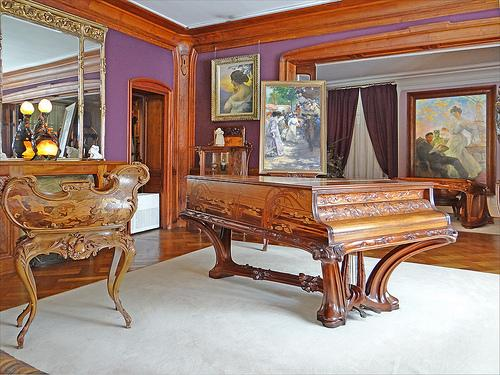Provide a concise description of the central item in the image and the color palette that dominates the scene. An engraved antique piano on a white rug highlights the scene, while tones of brown, white, and purple dominate the room's color scheme. Imagine that you are giving an audio tour of an art gallery, and describe the image as if it were a painting. Our eyes are drawn to the exquisite, engraved piano on a pristine white rug, against a backdrop of ornate furniture, fine art, and lush draperies. Write a vivid depiction of the setting portrayed in the image. The room showcases a stunning antique piano amid a mélange of framed artworks on the walls, rich purple décor, and light-drenched wooden floors. Mention the most eye-catching object in the image along with its notable details. An ornamental antique piano with curved legs exhibits intricate engravings and a closed key cover, sitting on a white rug. What is the main feature of this image, and how would you describe its appearance? The main feature is an ornate piano with engravings; it has a brown color and curved legs, placed on a large white carpet. Point out the primary object in the image and its surroundings that make it stand out. The ornately carved musical instrument occupies center stage, complemented by a white rug, brown floor, and charming artifacts. Narrate the scene in the image as if you were describing it to someone over the phone. In the image, there's an impressive, engraved antique piano centerpiece on a white rug, alongside framed paintings, a mirror, and decorative curtains. Describe how the different elements in the image come together to create an aesthetically pleasing scene. The antique piano, wooden floor, purple painted wall, and art pieces harmoniously blend to manifest an elegant and alluring atmosphere. Provide a brief description of the prominent piece of furniture and its surroundings in the image. An ornately carved grand piano rests on a white area rug, surrounded by a wooden floor, antique furniture, and various art pieces. Describe the atmosphere of the room depicted in the image, focusing on the most important object. The room exudes sophistication, featuring an antique wooden piano with curved legs as the focal point, amid a tasteful setting of artwork and furnishings. 